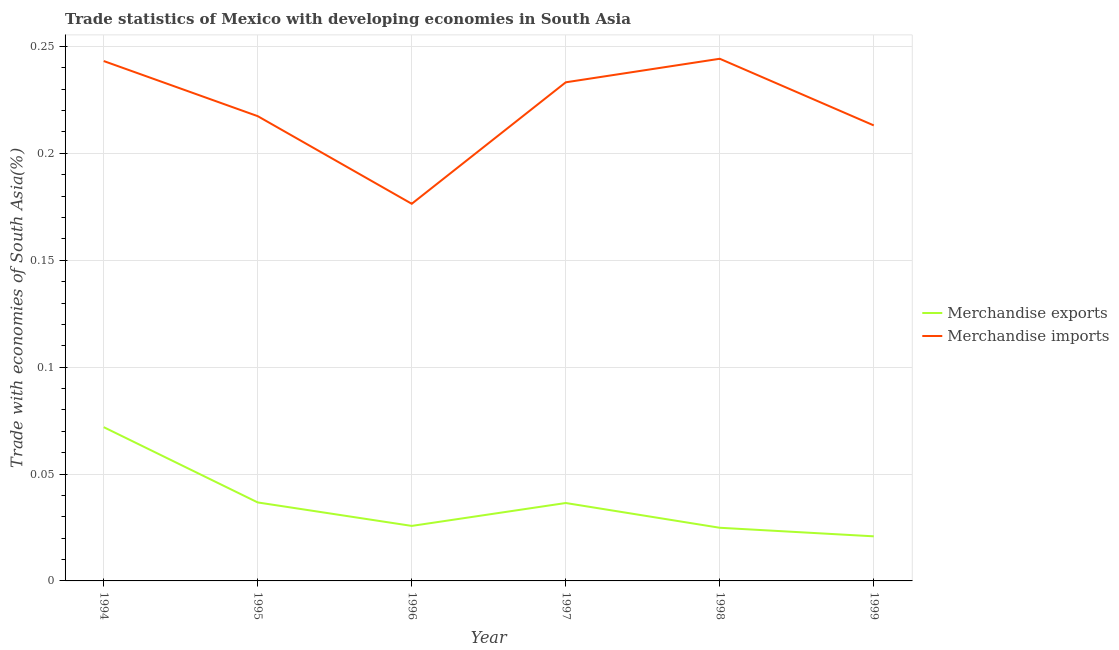Does the line corresponding to merchandise exports intersect with the line corresponding to merchandise imports?
Offer a very short reply. No. Is the number of lines equal to the number of legend labels?
Make the answer very short. Yes. What is the merchandise imports in 1999?
Your answer should be very brief. 0.21. Across all years, what is the maximum merchandise exports?
Keep it short and to the point. 0.07. Across all years, what is the minimum merchandise imports?
Make the answer very short. 0.18. In which year was the merchandise imports minimum?
Your answer should be very brief. 1996. What is the total merchandise exports in the graph?
Ensure brevity in your answer.  0.22. What is the difference between the merchandise exports in 1995 and that in 1997?
Your answer should be compact. 0. What is the difference between the merchandise imports in 1994 and the merchandise exports in 1996?
Offer a terse response. 0.22. What is the average merchandise exports per year?
Ensure brevity in your answer.  0.04. In the year 1995, what is the difference between the merchandise exports and merchandise imports?
Your response must be concise. -0.18. In how many years, is the merchandise exports greater than 0.02 %?
Ensure brevity in your answer.  6. What is the ratio of the merchandise exports in 1998 to that in 1999?
Keep it short and to the point. 1.19. Is the merchandise imports in 1995 less than that in 1997?
Give a very brief answer. Yes. Is the difference between the merchandise exports in 1996 and 1999 greater than the difference between the merchandise imports in 1996 and 1999?
Offer a terse response. Yes. What is the difference between the highest and the second highest merchandise exports?
Your answer should be compact. 0.04. What is the difference between the highest and the lowest merchandise imports?
Ensure brevity in your answer.  0.07. Does the merchandise imports monotonically increase over the years?
Make the answer very short. No. Does the graph contain grids?
Your response must be concise. Yes. What is the title of the graph?
Ensure brevity in your answer.  Trade statistics of Mexico with developing economies in South Asia. What is the label or title of the X-axis?
Make the answer very short. Year. What is the label or title of the Y-axis?
Provide a succinct answer. Trade with economies of South Asia(%). What is the Trade with economies of South Asia(%) of Merchandise exports in 1994?
Your answer should be compact. 0.07. What is the Trade with economies of South Asia(%) of Merchandise imports in 1994?
Keep it short and to the point. 0.24. What is the Trade with economies of South Asia(%) of Merchandise exports in 1995?
Ensure brevity in your answer.  0.04. What is the Trade with economies of South Asia(%) of Merchandise imports in 1995?
Ensure brevity in your answer.  0.22. What is the Trade with economies of South Asia(%) in Merchandise exports in 1996?
Give a very brief answer. 0.03. What is the Trade with economies of South Asia(%) of Merchandise imports in 1996?
Provide a succinct answer. 0.18. What is the Trade with economies of South Asia(%) in Merchandise exports in 1997?
Provide a succinct answer. 0.04. What is the Trade with economies of South Asia(%) in Merchandise imports in 1997?
Keep it short and to the point. 0.23. What is the Trade with economies of South Asia(%) of Merchandise exports in 1998?
Make the answer very short. 0.02. What is the Trade with economies of South Asia(%) in Merchandise imports in 1998?
Keep it short and to the point. 0.24. What is the Trade with economies of South Asia(%) in Merchandise exports in 1999?
Make the answer very short. 0.02. What is the Trade with economies of South Asia(%) of Merchandise imports in 1999?
Your answer should be very brief. 0.21. Across all years, what is the maximum Trade with economies of South Asia(%) in Merchandise exports?
Give a very brief answer. 0.07. Across all years, what is the maximum Trade with economies of South Asia(%) of Merchandise imports?
Keep it short and to the point. 0.24. Across all years, what is the minimum Trade with economies of South Asia(%) of Merchandise exports?
Offer a terse response. 0.02. Across all years, what is the minimum Trade with economies of South Asia(%) of Merchandise imports?
Your response must be concise. 0.18. What is the total Trade with economies of South Asia(%) of Merchandise exports in the graph?
Provide a short and direct response. 0.22. What is the total Trade with economies of South Asia(%) of Merchandise imports in the graph?
Give a very brief answer. 1.33. What is the difference between the Trade with economies of South Asia(%) in Merchandise exports in 1994 and that in 1995?
Offer a very short reply. 0.04. What is the difference between the Trade with economies of South Asia(%) in Merchandise imports in 1994 and that in 1995?
Your answer should be very brief. 0.03. What is the difference between the Trade with economies of South Asia(%) of Merchandise exports in 1994 and that in 1996?
Give a very brief answer. 0.05. What is the difference between the Trade with economies of South Asia(%) in Merchandise imports in 1994 and that in 1996?
Make the answer very short. 0.07. What is the difference between the Trade with economies of South Asia(%) of Merchandise exports in 1994 and that in 1997?
Keep it short and to the point. 0.04. What is the difference between the Trade with economies of South Asia(%) of Merchandise imports in 1994 and that in 1997?
Your answer should be very brief. 0.01. What is the difference between the Trade with economies of South Asia(%) of Merchandise exports in 1994 and that in 1998?
Provide a short and direct response. 0.05. What is the difference between the Trade with economies of South Asia(%) of Merchandise imports in 1994 and that in 1998?
Provide a short and direct response. -0. What is the difference between the Trade with economies of South Asia(%) of Merchandise exports in 1994 and that in 1999?
Keep it short and to the point. 0.05. What is the difference between the Trade with economies of South Asia(%) of Merchandise imports in 1994 and that in 1999?
Provide a succinct answer. 0.03. What is the difference between the Trade with economies of South Asia(%) of Merchandise exports in 1995 and that in 1996?
Offer a very short reply. 0.01. What is the difference between the Trade with economies of South Asia(%) of Merchandise imports in 1995 and that in 1996?
Your answer should be compact. 0.04. What is the difference between the Trade with economies of South Asia(%) of Merchandise exports in 1995 and that in 1997?
Keep it short and to the point. 0. What is the difference between the Trade with economies of South Asia(%) in Merchandise imports in 1995 and that in 1997?
Keep it short and to the point. -0.02. What is the difference between the Trade with economies of South Asia(%) of Merchandise exports in 1995 and that in 1998?
Keep it short and to the point. 0.01. What is the difference between the Trade with economies of South Asia(%) of Merchandise imports in 1995 and that in 1998?
Offer a terse response. -0.03. What is the difference between the Trade with economies of South Asia(%) in Merchandise exports in 1995 and that in 1999?
Provide a succinct answer. 0.02. What is the difference between the Trade with economies of South Asia(%) in Merchandise imports in 1995 and that in 1999?
Offer a very short reply. 0. What is the difference between the Trade with economies of South Asia(%) in Merchandise exports in 1996 and that in 1997?
Provide a short and direct response. -0.01. What is the difference between the Trade with economies of South Asia(%) in Merchandise imports in 1996 and that in 1997?
Keep it short and to the point. -0.06. What is the difference between the Trade with economies of South Asia(%) of Merchandise exports in 1996 and that in 1998?
Your response must be concise. 0. What is the difference between the Trade with economies of South Asia(%) of Merchandise imports in 1996 and that in 1998?
Provide a succinct answer. -0.07. What is the difference between the Trade with economies of South Asia(%) in Merchandise exports in 1996 and that in 1999?
Your answer should be very brief. 0. What is the difference between the Trade with economies of South Asia(%) in Merchandise imports in 1996 and that in 1999?
Give a very brief answer. -0.04. What is the difference between the Trade with economies of South Asia(%) in Merchandise exports in 1997 and that in 1998?
Your answer should be compact. 0.01. What is the difference between the Trade with economies of South Asia(%) of Merchandise imports in 1997 and that in 1998?
Offer a very short reply. -0.01. What is the difference between the Trade with economies of South Asia(%) in Merchandise exports in 1997 and that in 1999?
Provide a succinct answer. 0.02. What is the difference between the Trade with economies of South Asia(%) in Merchandise imports in 1997 and that in 1999?
Keep it short and to the point. 0.02. What is the difference between the Trade with economies of South Asia(%) of Merchandise exports in 1998 and that in 1999?
Ensure brevity in your answer.  0. What is the difference between the Trade with economies of South Asia(%) of Merchandise imports in 1998 and that in 1999?
Offer a very short reply. 0.03. What is the difference between the Trade with economies of South Asia(%) of Merchandise exports in 1994 and the Trade with economies of South Asia(%) of Merchandise imports in 1995?
Provide a succinct answer. -0.15. What is the difference between the Trade with economies of South Asia(%) in Merchandise exports in 1994 and the Trade with economies of South Asia(%) in Merchandise imports in 1996?
Give a very brief answer. -0.1. What is the difference between the Trade with economies of South Asia(%) in Merchandise exports in 1994 and the Trade with economies of South Asia(%) in Merchandise imports in 1997?
Provide a short and direct response. -0.16. What is the difference between the Trade with economies of South Asia(%) of Merchandise exports in 1994 and the Trade with economies of South Asia(%) of Merchandise imports in 1998?
Make the answer very short. -0.17. What is the difference between the Trade with economies of South Asia(%) of Merchandise exports in 1994 and the Trade with economies of South Asia(%) of Merchandise imports in 1999?
Your response must be concise. -0.14. What is the difference between the Trade with economies of South Asia(%) of Merchandise exports in 1995 and the Trade with economies of South Asia(%) of Merchandise imports in 1996?
Your answer should be compact. -0.14. What is the difference between the Trade with economies of South Asia(%) of Merchandise exports in 1995 and the Trade with economies of South Asia(%) of Merchandise imports in 1997?
Make the answer very short. -0.2. What is the difference between the Trade with economies of South Asia(%) of Merchandise exports in 1995 and the Trade with economies of South Asia(%) of Merchandise imports in 1998?
Ensure brevity in your answer.  -0.21. What is the difference between the Trade with economies of South Asia(%) in Merchandise exports in 1995 and the Trade with economies of South Asia(%) in Merchandise imports in 1999?
Provide a succinct answer. -0.18. What is the difference between the Trade with economies of South Asia(%) in Merchandise exports in 1996 and the Trade with economies of South Asia(%) in Merchandise imports in 1997?
Provide a succinct answer. -0.21. What is the difference between the Trade with economies of South Asia(%) in Merchandise exports in 1996 and the Trade with economies of South Asia(%) in Merchandise imports in 1998?
Offer a terse response. -0.22. What is the difference between the Trade with economies of South Asia(%) of Merchandise exports in 1996 and the Trade with economies of South Asia(%) of Merchandise imports in 1999?
Provide a short and direct response. -0.19. What is the difference between the Trade with economies of South Asia(%) in Merchandise exports in 1997 and the Trade with economies of South Asia(%) in Merchandise imports in 1998?
Provide a short and direct response. -0.21. What is the difference between the Trade with economies of South Asia(%) of Merchandise exports in 1997 and the Trade with economies of South Asia(%) of Merchandise imports in 1999?
Your answer should be very brief. -0.18. What is the difference between the Trade with economies of South Asia(%) of Merchandise exports in 1998 and the Trade with economies of South Asia(%) of Merchandise imports in 1999?
Keep it short and to the point. -0.19. What is the average Trade with economies of South Asia(%) of Merchandise exports per year?
Give a very brief answer. 0.04. What is the average Trade with economies of South Asia(%) in Merchandise imports per year?
Ensure brevity in your answer.  0.22. In the year 1994, what is the difference between the Trade with economies of South Asia(%) in Merchandise exports and Trade with economies of South Asia(%) in Merchandise imports?
Your answer should be very brief. -0.17. In the year 1995, what is the difference between the Trade with economies of South Asia(%) in Merchandise exports and Trade with economies of South Asia(%) in Merchandise imports?
Your answer should be compact. -0.18. In the year 1996, what is the difference between the Trade with economies of South Asia(%) of Merchandise exports and Trade with economies of South Asia(%) of Merchandise imports?
Your response must be concise. -0.15. In the year 1997, what is the difference between the Trade with economies of South Asia(%) of Merchandise exports and Trade with economies of South Asia(%) of Merchandise imports?
Provide a succinct answer. -0.2. In the year 1998, what is the difference between the Trade with economies of South Asia(%) of Merchandise exports and Trade with economies of South Asia(%) of Merchandise imports?
Make the answer very short. -0.22. In the year 1999, what is the difference between the Trade with economies of South Asia(%) in Merchandise exports and Trade with economies of South Asia(%) in Merchandise imports?
Ensure brevity in your answer.  -0.19. What is the ratio of the Trade with economies of South Asia(%) in Merchandise exports in 1994 to that in 1995?
Provide a short and direct response. 1.96. What is the ratio of the Trade with economies of South Asia(%) in Merchandise imports in 1994 to that in 1995?
Give a very brief answer. 1.12. What is the ratio of the Trade with economies of South Asia(%) of Merchandise exports in 1994 to that in 1996?
Offer a terse response. 2.79. What is the ratio of the Trade with economies of South Asia(%) in Merchandise imports in 1994 to that in 1996?
Provide a succinct answer. 1.38. What is the ratio of the Trade with economies of South Asia(%) in Merchandise exports in 1994 to that in 1997?
Your answer should be compact. 1.97. What is the ratio of the Trade with economies of South Asia(%) in Merchandise imports in 1994 to that in 1997?
Keep it short and to the point. 1.04. What is the ratio of the Trade with economies of South Asia(%) of Merchandise exports in 1994 to that in 1998?
Make the answer very short. 2.89. What is the ratio of the Trade with economies of South Asia(%) of Merchandise exports in 1994 to that in 1999?
Give a very brief answer. 3.45. What is the ratio of the Trade with economies of South Asia(%) of Merchandise imports in 1994 to that in 1999?
Provide a succinct answer. 1.14. What is the ratio of the Trade with economies of South Asia(%) in Merchandise exports in 1995 to that in 1996?
Your response must be concise. 1.43. What is the ratio of the Trade with economies of South Asia(%) in Merchandise imports in 1995 to that in 1996?
Keep it short and to the point. 1.23. What is the ratio of the Trade with economies of South Asia(%) of Merchandise exports in 1995 to that in 1997?
Offer a terse response. 1.01. What is the ratio of the Trade with economies of South Asia(%) in Merchandise imports in 1995 to that in 1997?
Offer a terse response. 0.93. What is the ratio of the Trade with economies of South Asia(%) of Merchandise exports in 1995 to that in 1998?
Your response must be concise. 1.48. What is the ratio of the Trade with economies of South Asia(%) of Merchandise imports in 1995 to that in 1998?
Keep it short and to the point. 0.89. What is the ratio of the Trade with economies of South Asia(%) in Merchandise exports in 1995 to that in 1999?
Make the answer very short. 1.76. What is the ratio of the Trade with economies of South Asia(%) in Merchandise imports in 1995 to that in 1999?
Your answer should be very brief. 1.02. What is the ratio of the Trade with economies of South Asia(%) in Merchandise exports in 1996 to that in 1997?
Your response must be concise. 0.71. What is the ratio of the Trade with economies of South Asia(%) in Merchandise imports in 1996 to that in 1997?
Offer a very short reply. 0.76. What is the ratio of the Trade with economies of South Asia(%) of Merchandise exports in 1996 to that in 1998?
Give a very brief answer. 1.03. What is the ratio of the Trade with economies of South Asia(%) in Merchandise imports in 1996 to that in 1998?
Your answer should be very brief. 0.72. What is the ratio of the Trade with economies of South Asia(%) of Merchandise exports in 1996 to that in 1999?
Give a very brief answer. 1.23. What is the ratio of the Trade with economies of South Asia(%) of Merchandise imports in 1996 to that in 1999?
Your answer should be compact. 0.83. What is the ratio of the Trade with economies of South Asia(%) of Merchandise exports in 1997 to that in 1998?
Provide a succinct answer. 1.47. What is the ratio of the Trade with economies of South Asia(%) of Merchandise imports in 1997 to that in 1998?
Give a very brief answer. 0.95. What is the ratio of the Trade with economies of South Asia(%) of Merchandise exports in 1997 to that in 1999?
Offer a very short reply. 1.75. What is the ratio of the Trade with economies of South Asia(%) of Merchandise imports in 1997 to that in 1999?
Offer a terse response. 1.09. What is the ratio of the Trade with economies of South Asia(%) of Merchandise exports in 1998 to that in 1999?
Your response must be concise. 1.19. What is the ratio of the Trade with economies of South Asia(%) in Merchandise imports in 1998 to that in 1999?
Offer a very short reply. 1.15. What is the difference between the highest and the second highest Trade with economies of South Asia(%) of Merchandise exports?
Keep it short and to the point. 0.04. What is the difference between the highest and the second highest Trade with economies of South Asia(%) in Merchandise imports?
Make the answer very short. 0. What is the difference between the highest and the lowest Trade with economies of South Asia(%) in Merchandise exports?
Ensure brevity in your answer.  0.05. What is the difference between the highest and the lowest Trade with economies of South Asia(%) in Merchandise imports?
Offer a very short reply. 0.07. 